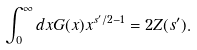Convert formula to latex. <formula><loc_0><loc_0><loc_500><loc_500>\int _ { 0 } ^ { \infty } d x G ( x ) x ^ { s ^ { \prime } / 2 - 1 } = 2 Z ( s ^ { \prime } ) .</formula> 